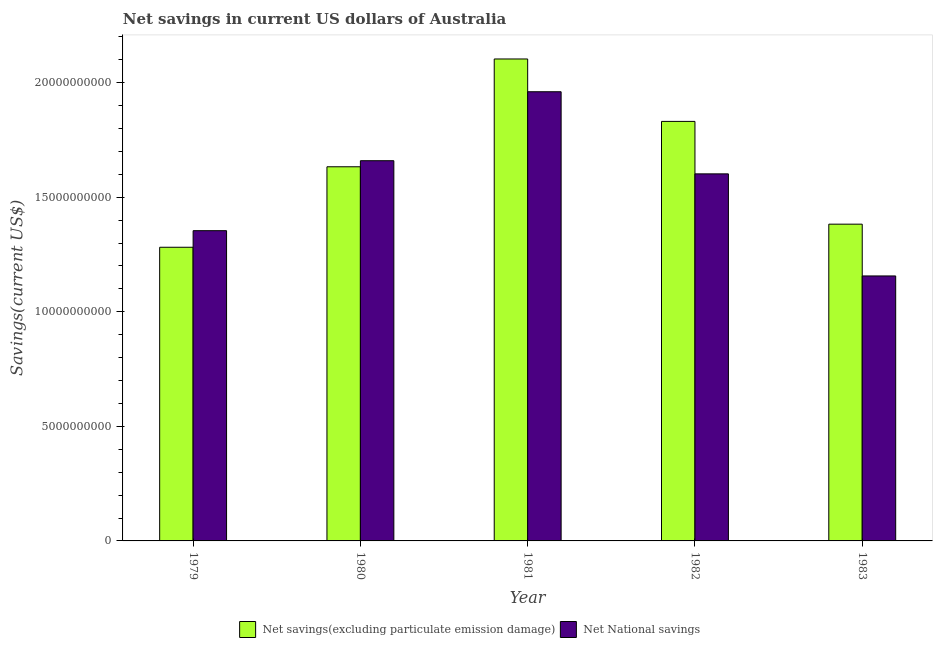How many different coloured bars are there?
Ensure brevity in your answer.  2. Are the number of bars on each tick of the X-axis equal?
Give a very brief answer. Yes. How many bars are there on the 5th tick from the left?
Keep it short and to the point. 2. What is the label of the 5th group of bars from the left?
Offer a very short reply. 1983. In how many cases, is the number of bars for a given year not equal to the number of legend labels?
Your answer should be compact. 0. What is the net savings(excluding particulate emission damage) in 1981?
Provide a succinct answer. 2.10e+1. Across all years, what is the maximum net national savings?
Offer a terse response. 1.96e+1. Across all years, what is the minimum net national savings?
Make the answer very short. 1.16e+1. In which year was the net national savings maximum?
Offer a terse response. 1981. In which year was the net national savings minimum?
Your response must be concise. 1983. What is the total net national savings in the graph?
Offer a terse response. 7.73e+1. What is the difference between the net national savings in 1980 and that in 1982?
Ensure brevity in your answer.  5.74e+08. What is the difference between the net savings(excluding particulate emission damage) in 1979 and the net national savings in 1980?
Your answer should be compact. -3.51e+09. What is the average net national savings per year?
Provide a succinct answer. 1.55e+1. What is the ratio of the net savings(excluding particulate emission damage) in 1979 to that in 1983?
Your answer should be very brief. 0.93. Is the net national savings in 1980 less than that in 1982?
Offer a terse response. No. Is the difference between the net national savings in 1981 and 1982 greater than the difference between the net savings(excluding particulate emission damage) in 1981 and 1982?
Make the answer very short. No. What is the difference between the highest and the second highest net national savings?
Your answer should be compact. 3.01e+09. What is the difference between the highest and the lowest net national savings?
Keep it short and to the point. 8.04e+09. What does the 2nd bar from the left in 1983 represents?
Give a very brief answer. Net National savings. What does the 1st bar from the right in 1983 represents?
Offer a very short reply. Net National savings. Are all the bars in the graph horizontal?
Offer a terse response. No. How many years are there in the graph?
Provide a succinct answer. 5. What is the difference between two consecutive major ticks on the Y-axis?
Offer a very short reply. 5.00e+09. Does the graph contain any zero values?
Provide a succinct answer. No. Does the graph contain grids?
Your response must be concise. No. How many legend labels are there?
Your response must be concise. 2. What is the title of the graph?
Provide a short and direct response. Net savings in current US dollars of Australia. What is the label or title of the X-axis?
Offer a terse response. Year. What is the label or title of the Y-axis?
Make the answer very short. Savings(current US$). What is the Savings(current US$) of Net savings(excluding particulate emission damage) in 1979?
Your answer should be compact. 1.28e+1. What is the Savings(current US$) in Net National savings in 1979?
Make the answer very short. 1.35e+1. What is the Savings(current US$) of Net savings(excluding particulate emission damage) in 1980?
Your answer should be compact. 1.63e+1. What is the Savings(current US$) in Net National savings in 1980?
Your answer should be compact. 1.66e+1. What is the Savings(current US$) in Net savings(excluding particulate emission damage) in 1981?
Ensure brevity in your answer.  2.10e+1. What is the Savings(current US$) in Net National savings in 1981?
Offer a very short reply. 1.96e+1. What is the Savings(current US$) of Net savings(excluding particulate emission damage) in 1982?
Provide a short and direct response. 1.83e+1. What is the Savings(current US$) of Net National savings in 1982?
Ensure brevity in your answer.  1.60e+1. What is the Savings(current US$) of Net savings(excluding particulate emission damage) in 1983?
Give a very brief answer. 1.38e+1. What is the Savings(current US$) in Net National savings in 1983?
Offer a terse response. 1.16e+1. Across all years, what is the maximum Savings(current US$) in Net savings(excluding particulate emission damage)?
Provide a succinct answer. 2.10e+1. Across all years, what is the maximum Savings(current US$) of Net National savings?
Your answer should be very brief. 1.96e+1. Across all years, what is the minimum Savings(current US$) of Net savings(excluding particulate emission damage)?
Your answer should be compact. 1.28e+1. Across all years, what is the minimum Savings(current US$) of Net National savings?
Your response must be concise. 1.16e+1. What is the total Savings(current US$) of Net savings(excluding particulate emission damage) in the graph?
Offer a very short reply. 8.23e+1. What is the total Savings(current US$) of Net National savings in the graph?
Offer a terse response. 7.73e+1. What is the difference between the Savings(current US$) in Net savings(excluding particulate emission damage) in 1979 and that in 1980?
Offer a very short reply. -3.51e+09. What is the difference between the Savings(current US$) in Net National savings in 1979 and that in 1980?
Provide a short and direct response. -3.05e+09. What is the difference between the Savings(current US$) of Net savings(excluding particulate emission damage) in 1979 and that in 1981?
Ensure brevity in your answer.  -8.22e+09. What is the difference between the Savings(current US$) in Net National savings in 1979 and that in 1981?
Your answer should be very brief. -6.06e+09. What is the difference between the Savings(current US$) of Net savings(excluding particulate emission damage) in 1979 and that in 1982?
Your answer should be very brief. -5.49e+09. What is the difference between the Savings(current US$) of Net National savings in 1979 and that in 1982?
Ensure brevity in your answer.  -2.48e+09. What is the difference between the Savings(current US$) in Net savings(excluding particulate emission damage) in 1979 and that in 1983?
Offer a terse response. -1.01e+09. What is the difference between the Savings(current US$) in Net National savings in 1979 and that in 1983?
Your response must be concise. 1.98e+09. What is the difference between the Savings(current US$) in Net savings(excluding particulate emission damage) in 1980 and that in 1981?
Make the answer very short. -4.70e+09. What is the difference between the Savings(current US$) of Net National savings in 1980 and that in 1981?
Provide a short and direct response. -3.01e+09. What is the difference between the Savings(current US$) of Net savings(excluding particulate emission damage) in 1980 and that in 1982?
Keep it short and to the point. -1.98e+09. What is the difference between the Savings(current US$) in Net National savings in 1980 and that in 1982?
Provide a succinct answer. 5.74e+08. What is the difference between the Savings(current US$) in Net savings(excluding particulate emission damage) in 1980 and that in 1983?
Provide a short and direct response. 2.50e+09. What is the difference between the Savings(current US$) in Net National savings in 1980 and that in 1983?
Offer a terse response. 5.03e+09. What is the difference between the Savings(current US$) in Net savings(excluding particulate emission damage) in 1981 and that in 1982?
Provide a short and direct response. 2.72e+09. What is the difference between the Savings(current US$) of Net National savings in 1981 and that in 1982?
Offer a very short reply. 3.58e+09. What is the difference between the Savings(current US$) in Net savings(excluding particulate emission damage) in 1981 and that in 1983?
Give a very brief answer. 7.21e+09. What is the difference between the Savings(current US$) of Net National savings in 1981 and that in 1983?
Your response must be concise. 8.04e+09. What is the difference between the Savings(current US$) in Net savings(excluding particulate emission damage) in 1982 and that in 1983?
Your answer should be compact. 4.48e+09. What is the difference between the Savings(current US$) of Net National savings in 1982 and that in 1983?
Your answer should be very brief. 4.46e+09. What is the difference between the Savings(current US$) of Net savings(excluding particulate emission damage) in 1979 and the Savings(current US$) of Net National savings in 1980?
Offer a terse response. -3.78e+09. What is the difference between the Savings(current US$) of Net savings(excluding particulate emission damage) in 1979 and the Savings(current US$) of Net National savings in 1981?
Provide a short and direct response. -6.79e+09. What is the difference between the Savings(current US$) in Net savings(excluding particulate emission damage) in 1979 and the Savings(current US$) in Net National savings in 1982?
Offer a very short reply. -3.20e+09. What is the difference between the Savings(current US$) of Net savings(excluding particulate emission damage) in 1979 and the Savings(current US$) of Net National savings in 1983?
Make the answer very short. 1.25e+09. What is the difference between the Savings(current US$) of Net savings(excluding particulate emission damage) in 1980 and the Savings(current US$) of Net National savings in 1981?
Give a very brief answer. -3.27e+09. What is the difference between the Savings(current US$) of Net savings(excluding particulate emission damage) in 1980 and the Savings(current US$) of Net National savings in 1982?
Provide a short and direct response. 3.10e+08. What is the difference between the Savings(current US$) in Net savings(excluding particulate emission damage) in 1980 and the Savings(current US$) in Net National savings in 1983?
Your answer should be very brief. 4.76e+09. What is the difference between the Savings(current US$) in Net savings(excluding particulate emission damage) in 1981 and the Savings(current US$) in Net National savings in 1982?
Provide a short and direct response. 5.01e+09. What is the difference between the Savings(current US$) of Net savings(excluding particulate emission damage) in 1981 and the Savings(current US$) of Net National savings in 1983?
Your response must be concise. 9.47e+09. What is the difference between the Savings(current US$) in Net savings(excluding particulate emission damage) in 1982 and the Savings(current US$) in Net National savings in 1983?
Your response must be concise. 6.74e+09. What is the average Savings(current US$) of Net savings(excluding particulate emission damage) per year?
Offer a terse response. 1.65e+1. What is the average Savings(current US$) of Net National savings per year?
Ensure brevity in your answer.  1.55e+1. In the year 1979, what is the difference between the Savings(current US$) in Net savings(excluding particulate emission damage) and Savings(current US$) in Net National savings?
Provide a short and direct response. -7.24e+08. In the year 1980, what is the difference between the Savings(current US$) in Net savings(excluding particulate emission damage) and Savings(current US$) in Net National savings?
Offer a terse response. -2.64e+08. In the year 1981, what is the difference between the Savings(current US$) in Net savings(excluding particulate emission damage) and Savings(current US$) in Net National savings?
Make the answer very short. 1.43e+09. In the year 1982, what is the difference between the Savings(current US$) of Net savings(excluding particulate emission damage) and Savings(current US$) of Net National savings?
Offer a very short reply. 2.29e+09. In the year 1983, what is the difference between the Savings(current US$) in Net savings(excluding particulate emission damage) and Savings(current US$) in Net National savings?
Ensure brevity in your answer.  2.26e+09. What is the ratio of the Savings(current US$) in Net savings(excluding particulate emission damage) in 1979 to that in 1980?
Make the answer very short. 0.78. What is the ratio of the Savings(current US$) of Net National savings in 1979 to that in 1980?
Offer a terse response. 0.82. What is the ratio of the Savings(current US$) of Net savings(excluding particulate emission damage) in 1979 to that in 1981?
Offer a very short reply. 0.61. What is the ratio of the Savings(current US$) in Net National savings in 1979 to that in 1981?
Offer a terse response. 0.69. What is the ratio of the Savings(current US$) of Net savings(excluding particulate emission damage) in 1979 to that in 1982?
Make the answer very short. 0.7. What is the ratio of the Savings(current US$) in Net National savings in 1979 to that in 1982?
Ensure brevity in your answer.  0.85. What is the ratio of the Savings(current US$) in Net savings(excluding particulate emission damage) in 1979 to that in 1983?
Your answer should be very brief. 0.93. What is the ratio of the Savings(current US$) of Net National savings in 1979 to that in 1983?
Provide a short and direct response. 1.17. What is the ratio of the Savings(current US$) in Net savings(excluding particulate emission damage) in 1980 to that in 1981?
Ensure brevity in your answer.  0.78. What is the ratio of the Savings(current US$) in Net National savings in 1980 to that in 1981?
Provide a succinct answer. 0.85. What is the ratio of the Savings(current US$) of Net savings(excluding particulate emission damage) in 1980 to that in 1982?
Make the answer very short. 0.89. What is the ratio of the Savings(current US$) of Net National savings in 1980 to that in 1982?
Offer a very short reply. 1.04. What is the ratio of the Savings(current US$) of Net savings(excluding particulate emission damage) in 1980 to that in 1983?
Give a very brief answer. 1.18. What is the ratio of the Savings(current US$) of Net National savings in 1980 to that in 1983?
Provide a short and direct response. 1.43. What is the ratio of the Savings(current US$) in Net savings(excluding particulate emission damage) in 1981 to that in 1982?
Provide a short and direct response. 1.15. What is the ratio of the Savings(current US$) in Net National savings in 1981 to that in 1982?
Give a very brief answer. 1.22. What is the ratio of the Savings(current US$) of Net savings(excluding particulate emission damage) in 1981 to that in 1983?
Give a very brief answer. 1.52. What is the ratio of the Savings(current US$) in Net National savings in 1981 to that in 1983?
Make the answer very short. 1.7. What is the ratio of the Savings(current US$) in Net savings(excluding particulate emission damage) in 1982 to that in 1983?
Ensure brevity in your answer.  1.32. What is the ratio of the Savings(current US$) of Net National savings in 1982 to that in 1983?
Provide a succinct answer. 1.39. What is the difference between the highest and the second highest Savings(current US$) in Net savings(excluding particulate emission damage)?
Your answer should be compact. 2.72e+09. What is the difference between the highest and the second highest Savings(current US$) of Net National savings?
Your answer should be very brief. 3.01e+09. What is the difference between the highest and the lowest Savings(current US$) in Net savings(excluding particulate emission damage)?
Your answer should be compact. 8.22e+09. What is the difference between the highest and the lowest Savings(current US$) of Net National savings?
Provide a succinct answer. 8.04e+09. 